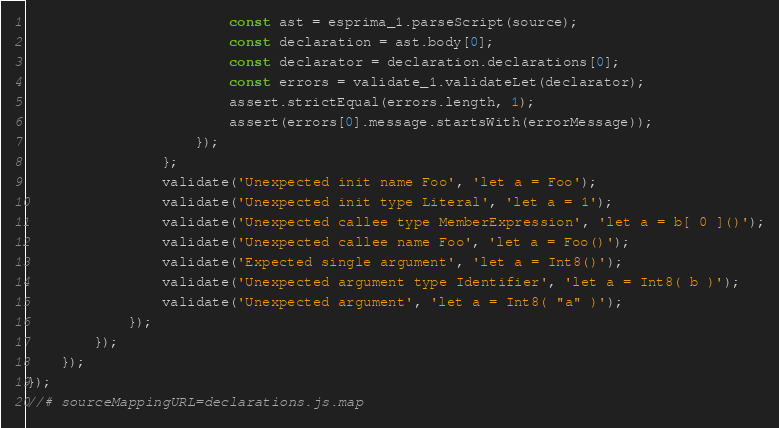<code> <loc_0><loc_0><loc_500><loc_500><_JavaScript_>                        const ast = esprima_1.parseScript(source);
                        const declaration = ast.body[0];
                        const declarator = declaration.declarations[0];
                        const errors = validate_1.validateLet(declarator);
                        assert.strictEqual(errors.length, 1);
                        assert(errors[0].message.startsWith(errorMessage));
                    });
                };
                validate('Unexpected init name Foo', 'let a = Foo');
                validate('Unexpected init type Literal', 'let a = 1');
                validate('Unexpected callee type MemberExpression', 'let a = b[ 0 ]()');
                validate('Unexpected callee name Foo', 'let a = Foo()');
                validate('Expected single argument', 'let a = Int8()');
                validate('Unexpected argument type Identifier', 'let a = Int8( b )');
                validate('Unexpected argument', 'let a = Int8( "a" )');
            });
        });
    });
});
//# sourceMappingURL=declarations.js.map</code> 